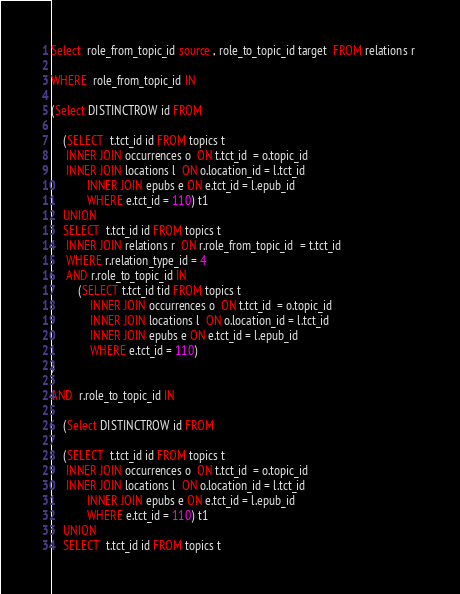Convert code to text. <code><loc_0><loc_0><loc_500><loc_500><_SQL_>Select  role_from_topic_id source , role_to_topic_id target  FROM relations r 

WHERE  role_from_topic_id IN 

(Select DISTINCTROW id FROM 

    (SELECT  t.tct_id id FROM topics t
     INNER JOIN occurrences o  ON t.tct_id  = o.topic_id
     INNER JOIN locations l  ON o.location_id = l.tct_id
            INNER JOIN epubs e ON e.tct_id = l.epub_id
            WHERE e.tct_id = 110) t1
    UNION 
    SELECT  t.tct_id id FROM topics t
     INNER JOIN relations r  ON r.role_from_topic_id  = t.tct_id
     WHERE r.relation_type_id = 4 
     AND r.role_to_topic_id IN 
         (SELECT t.tct_id tid FROM topics t
             INNER JOIN occurrences o  ON t.tct_id  = o.topic_id
             INNER JOIN locations l  ON o.location_id = l.tct_id
             INNER JOIN epubs e ON e.tct_id = l.epub_id
             WHERE e.tct_id = 110) 
) 
             
AND  r.role_to_topic_id IN  

    (Select DISTINCTROW id FROM 

    (SELECT  t.tct_id id FROM topics t
     INNER JOIN occurrences o  ON t.tct_id  = o.topic_id
     INNER JOIN locations l  ON o.location_id = l.tct_id
            INNER JOIN epubs e ON e.tct_id = l.epub_id
            WHERE e.tct_id = 110) t1
    UNION 
    SELECT  t.tct_id id FROM topics t</code> 